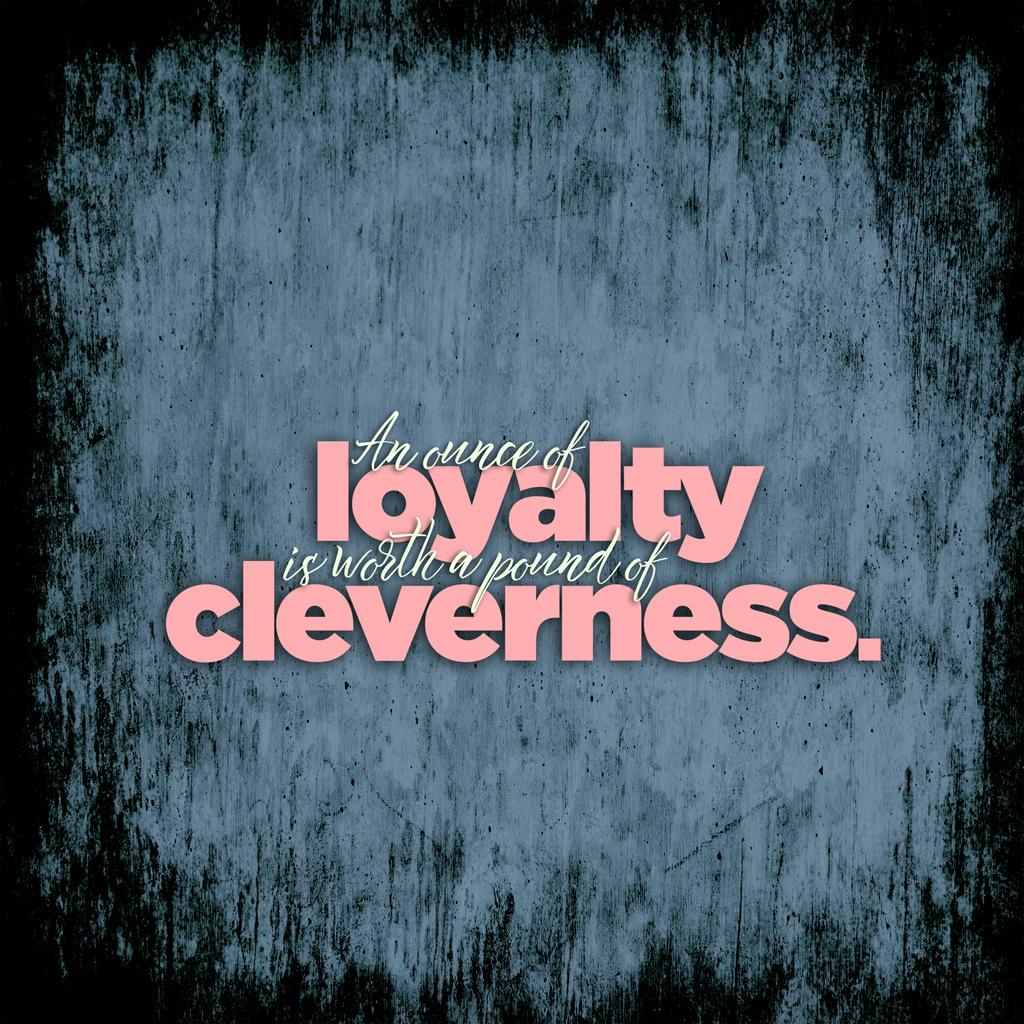<image>
Write a terse but informative summary of the picture. a saying in pink that has loyalty and cleverness emphasized 